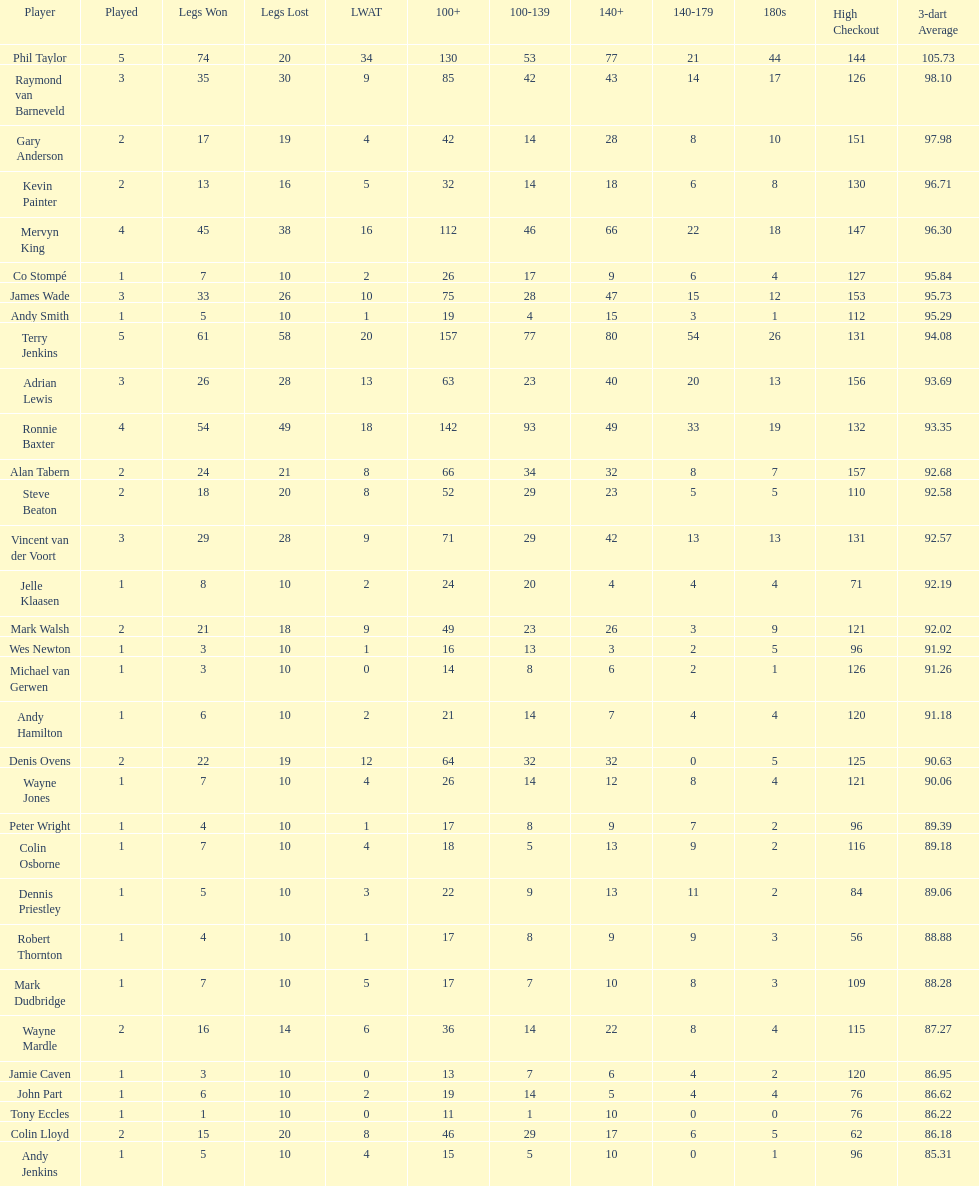Was andy smith or kevin painter's 3-dart average 96.71? Kevin Painter. 